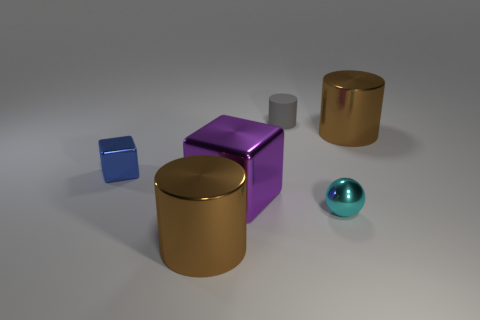Is the material of the gray thing the same as the purple cube? Based on the image, the gray object appears to be matte and less reflective compared to the purple cube, which has a shiny surface, suggesting different material properties or finishes. 